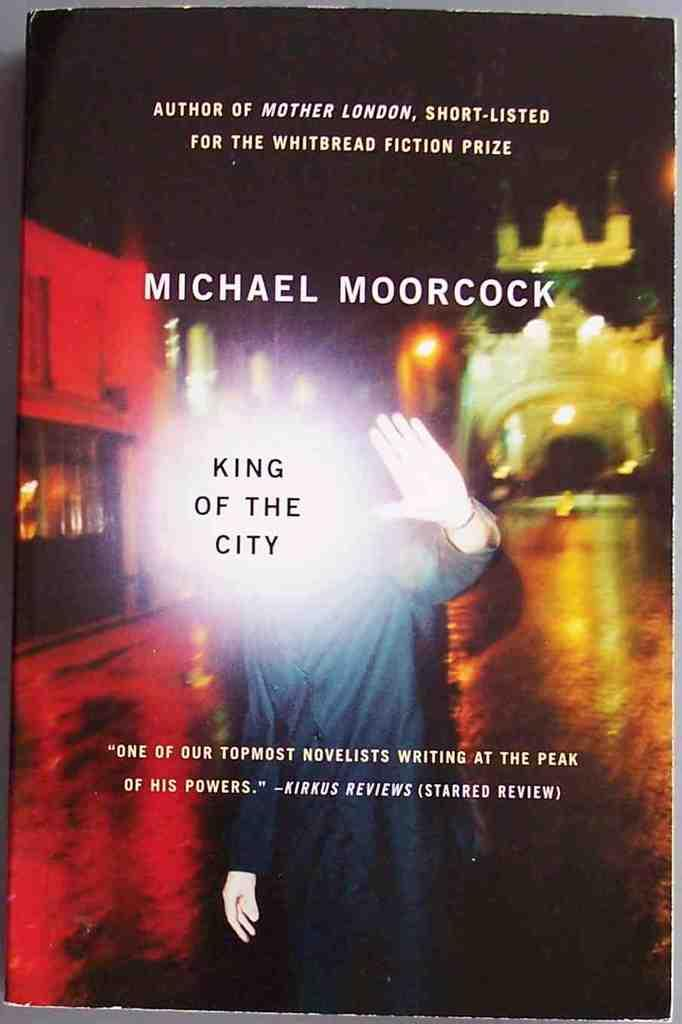<image>
Provide a brief description of the given image. A bright light and King of the City blocks of the face of the person on a book cover. 